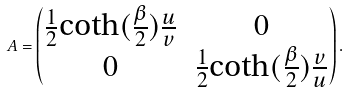<formula> <loc_0><loc_0><loc_500><loc_500>A = \begin{pmatrix} \frac { 1 } { 2 } \text {coth} ( \frac { \beta } { 2 } ) \frac { u } { v } & 0 \\ 0 & \frac { 1 } { 2 } \text {coth} ( \frac { \beta } { 2 } ) \frac { v } { u } \end{pmatrix} .</formula> 